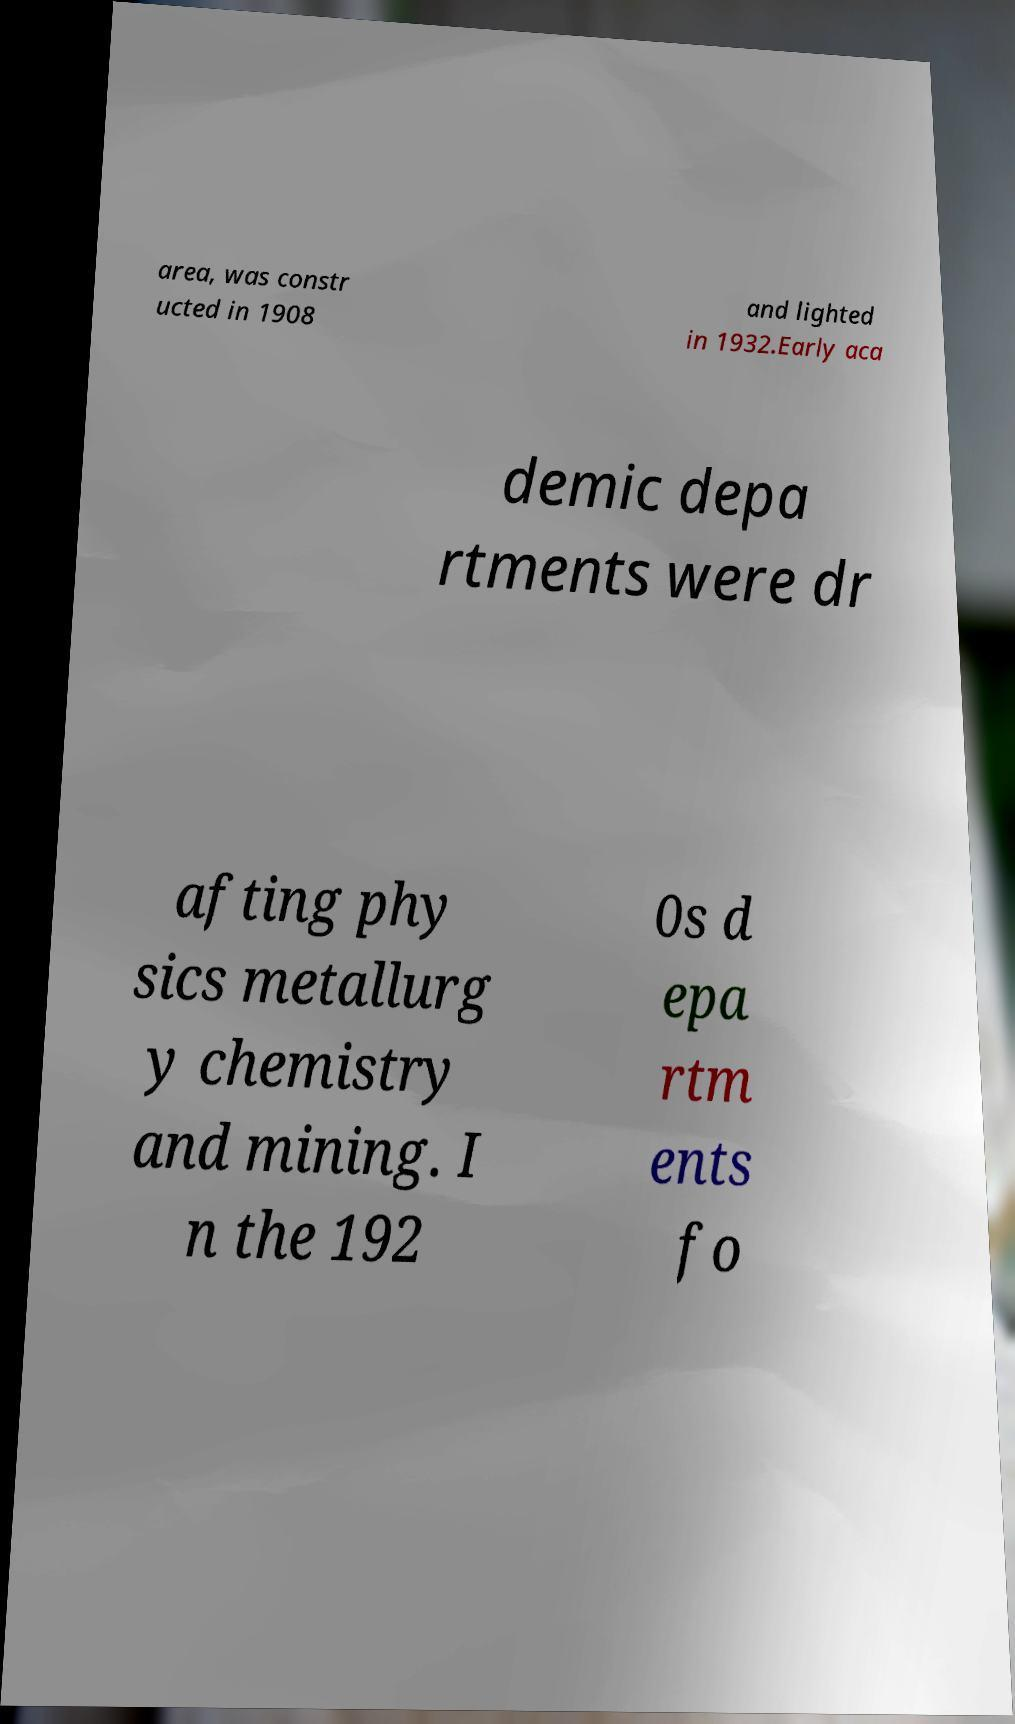Can you read and provide the text displayed in the image?This photo seems to have some interesting text. Can you extract and type it out for me? area, was constr ucted in 1908 and lighted in 1932.Early aca demic depa rtments were dr afting phy sics metallurg y chemistry and mining. I n the 192 0s d epa rtm ents fo 